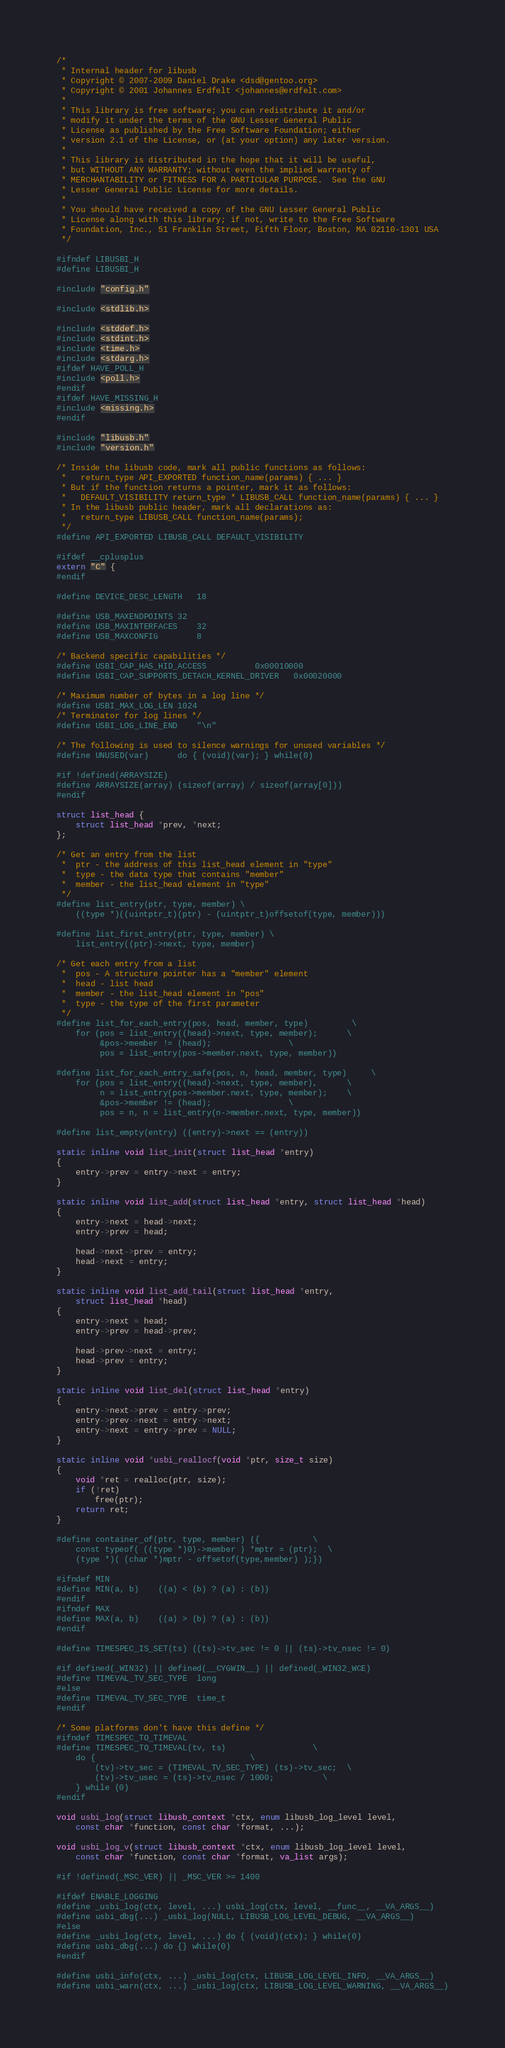Convert code to text. <code><loc_0><loc_0><loc_500><loc_500><_C_>/*
 * Internal header for libusb
 * Copyright © 2007-2009 Daniel Drake <dsd@gentoo.org>
 * Copyright © 2001 Johannes Erdfelt <johannes@erdfelt.com>
 *
 * This library is free software; you can redistribute it and/or
 * modify it under the terms of the GNU Lesser General Public
 * License as published by the Free Software Foundation; either
 * version 2.1 of the License, or (at your option) any later version.
 *
 * This library is distributed in the hope that it will be useful,
 * but WITHOUT ANY WARRANTY; without even the implied warranty of
 * MERCHANTABILITY or FITNESS FOR A PARTICULAR PURPOSE.  See the GNU
 * Lesser General Public License for more details.
 *
 * You should have received a copy of the GNU Lesser General Public
 * License along with this library; if not, write to the Free Software
 * Foundation, Inc., 51 Franklin Street, Fifth Floor, Boston, MA 02110-1301 USA
 */

#ifndef LIBUSBI_H
#define LIBUSBI_H

#include "config.h"

#include <stdlib.h>

#include <stddef.h>
#include <stdint.h>
#include <time.h>
#include <stdarg.h>
#ifdef HAVE_POLL_H
#include <poll.h>
#endif
#ifdef HAVE_MISSING_H
#include <missing.h>
#endif

#include "libusb.h"
#include "version.h"

/* Inside the libusb code, mark all public functions as follows:
 *   return_type API_EXPORTED function_name(params) { ... }
 * But if the function returns a pointer, mark it as follows:
 *   DEFAULT_VISIBILITY return_type * LIBUSB_CALL function_name(params) { ... }
 * In the libusb public header, mark all declarations as:
 *   return_type LIBUSB_CALL function_name(params);
 */
#define API_EXPORTED LIBUSB_CALL DEFAULT_VISIBILITY

#ifdef __cplusplus
extern "C" {
#endif

#define DEVICE_DESC_LENGTH	18

#define USB_MAXENDPOINTS	32
#define USB_MAXINTERFACES	32
#define USB_MAXCONFIG		8

/* Backend specific capabilities */
#define USBI_CAP_HAS_HID_ACCESS			0x00010000
#define USBI_CAP_SUPPORTS_DETACH_KERNEL_DRIVER	0x00020000

/* Maximum number of bytes in a log line */
#define USBI_MAX_LOG_LEN	1024
/* Terminator for log lines */
#define USBI_LOG_LINE_END	"\n"

/* The following is used to silence warnings for unused variables */
#define UNUSED(var)		do { (void)(var); } while(0)

#if !defined(ARRAYSIZE)
#define ARRAYSIZE(array) (sizeof(array) / sizeof(array[0]))
#endif

struct list_head {
	struct list_head *prev, *next;
};

/* Get an entry from the list
 *  ptr - the address of this list_head element in "type"
 *  type - the data type that contains "member"
 *  member - the list_head element in "type"
 */
#define list_entry(ptr, type, member) \
	((type *)((uintptr_t)(ptr) - (uintptr_t)offsetof(type, member)))

#define list_first_entry(ptr, type, member) \
	list_entry((ptr)->next, type, member)

/* Get each entry from a list
 *  pos - A structure pointer has a "member" element
 *  head - list head
 *  member - the list_head element in "pos"
 *  type - the type of the first parameter
 */
#define list_for_each_entry(pos, head, member, type)			\
	for (pos = list_entry((head)->next, type, member);		\
		 &pos->member != (head);				\
		 pos = list_entry(pos->member.next, type, member))

#define list_for_each_entry_safe(pos, n, head, member, type)		\
	for (pos = list_entry((head)->next, type, member),		\
		 n = list_entry(pos->member.next, type, member);	\
		 &pos->member != (head);				\
		 pos = n, n = list_entry(n->member.next, type, member))

#define list_empty(entry) ((entry)->next == (entry))

static inline void list_init(struct list_head *entry)
{
	entry->prev = entry->next = entry;
}

static inline void list_add(struct list_head *entry, struct list_head *head)
{
	entry->next = head->next;
	entry->prev = head;

	head->next->prev = entry;
	head->next = entry;
}

static inline void list_add_tail(struct list_head *entry,
	struct list_head *head)
{
	entry->next = head;
	entry->prev = head->prev;

	head->prev->next = entry;
	head->prev = entry;
}

static inline void list_del(struct list_head *entry)
{
	entry->next->prev = entry->prev;
	entry->prev->next = entry->next;
	entry->next = entry->prev = NULL;
}

static inline void *usbi_reallocf(void *ptr, size_t size)
{
	void *ret = realloc(ptr, size);
	if (!ret)
		free(ptr);
	return ret;
}

#define container_of(ptr, type, member) ({			\
	const typeof( ((type *)0)->member ) *mptr = (ptr);	\
	(type *)( (char *)mptr - offsetof(type,member) );})

#ifndef MIN
#define MIN(a, b)	((a) < (b) ? (a) : (b))
#endif
#ifndef MAX
#define MAX(a, b)	((a) > (b) ? (a) : (b))
#endif

#define TIMESPEC_IS_SET(ts) ((ts)->tv_sec != 0 || (ts)->tv_nsec != 0)

#if defined(_WIN32) || defined(__CYGWIN__) || defined(_WIN32_WCE)
#define TIMEVAL_TV_SEC_TYPE	long
#else
#define TIMEVAL_TV_SEC_TYPE	time_t
#endif

/* Some platforms don't have this define */
#ifndef TIMESPEC_TO_TIMEVAL
#define TIMESPEC_TO_TIMEVAL(tv, ts)					\
	do {								\
		(tv)->tv_sec = (TIMEVAL_TV_SEC_TYPE) (ts)->tv_sec;	\
		(tv)->tv_usec = (ts)->tv_nsec / 1000;			\
	} while (0)
#endif

void usbi_log(struct libusb_context *ctx, enum libusb_log_level level,
	const char *function, const char *format, ...);

void usbi_log_v(struct libusb_context *ctx, enum libusb_log_level level,
	const char *function, const char *format, va_list args);

#if !defined(_MSC_VER) || _MSC_VER >= 1400

#ifdef ENABLE_LOGGING
#define _usbi_log(ctx, level, ...) usbi_log(ctx, level, __func__, __VA_ARGS__)
#define usbi_dbg(...) _usbi_log(NULL, LIBUSB_LOG_LEVEL_DEBUG, __VA_ARGS__)
#else
#define _usbi_log(ctx, level, ...) do { (void)(ctx); } while(0)
#define usbi_dbg(...) do {} while(0)
#endif

#define usbi_info(ctx, ...) _usbi_log(ctx, LIBUSB_LOG_LEVEL_INFO, __VA_ARGS__)
#define usbi_warn(ctx, ...) _usbi_log(ctx, LIBUSB_LOG_LEVEL_WARNING, __VA_ARGS__)</code> 